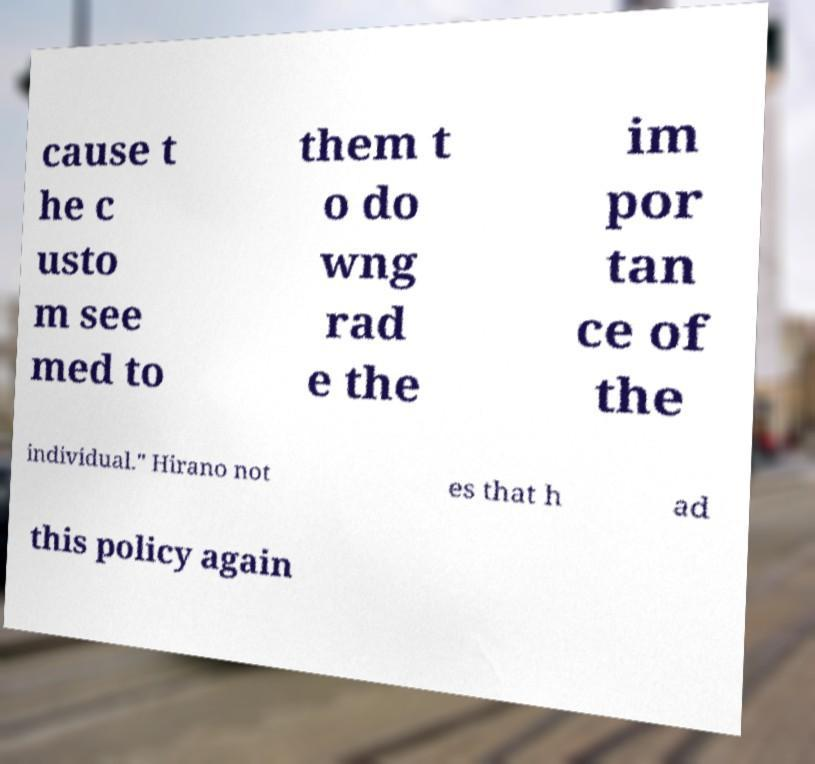For documentation purposes, I need the text within this image transcribed. Could you provide that? cause t he c usto m see med to them t o do wng rad e the im por tan ce of the individual." Hirano not es that h ad this policy again 